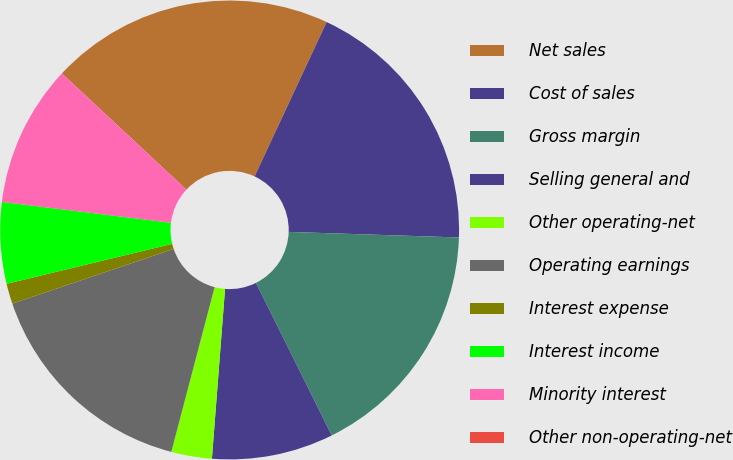Convert chart to OTSL. <chart><loc_0><loc_0><loc_500><loc_500><pie_chart><fcel>Net sales<fcel>Cost of sales<fcel>Gross margin<fcel>Selling general and<fcel>Other operating-net<fcel>Operating earnings<fcel>Interest expense<fcel>Interest income<fcel>Minority interest<fcel>Other non-operating-net<nl><fcel>20.0%<fcel>18.57%<fcel>17.14%<fcel>8.57%<fcel>2.86%<fcel>15.71%<fcel>1.43%<fcel>5.72%<fcel>10.0%<fcel>0.0%<nl></chart> 